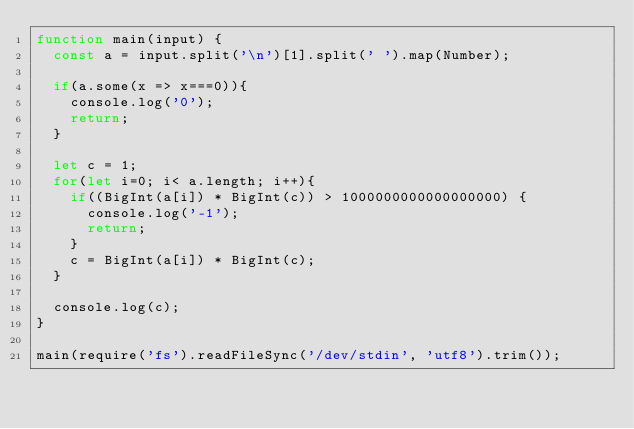<code> <loc_0><loc_0><loc_500><loc_500><_JavaScript_>function main(input) {
  const a = input.split('\n')[1].split(' ').map(Number);

  if(a.some(x => x===0)){
    console.log('0');
    return;
  }

  let c = 1;
  for(let i=0; i< a.length; i++){
    if((BigInt(a[i]) * BigInt(c)) > 1000000000000000000) {
      console.log('-1');
      return;
    }
    c = BigInt(a[i]) * BigInt(c);
  }

  console.log(c);
}

main(require('fs').readFileSync('/dev/stdin', 'utf8').trim());
</code> 